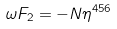<formula> <loc_0><loc_0><loc_500><loc_500>\omega F _ { 2 } = - N \eta ^ { 4 5 6 }</formula> 